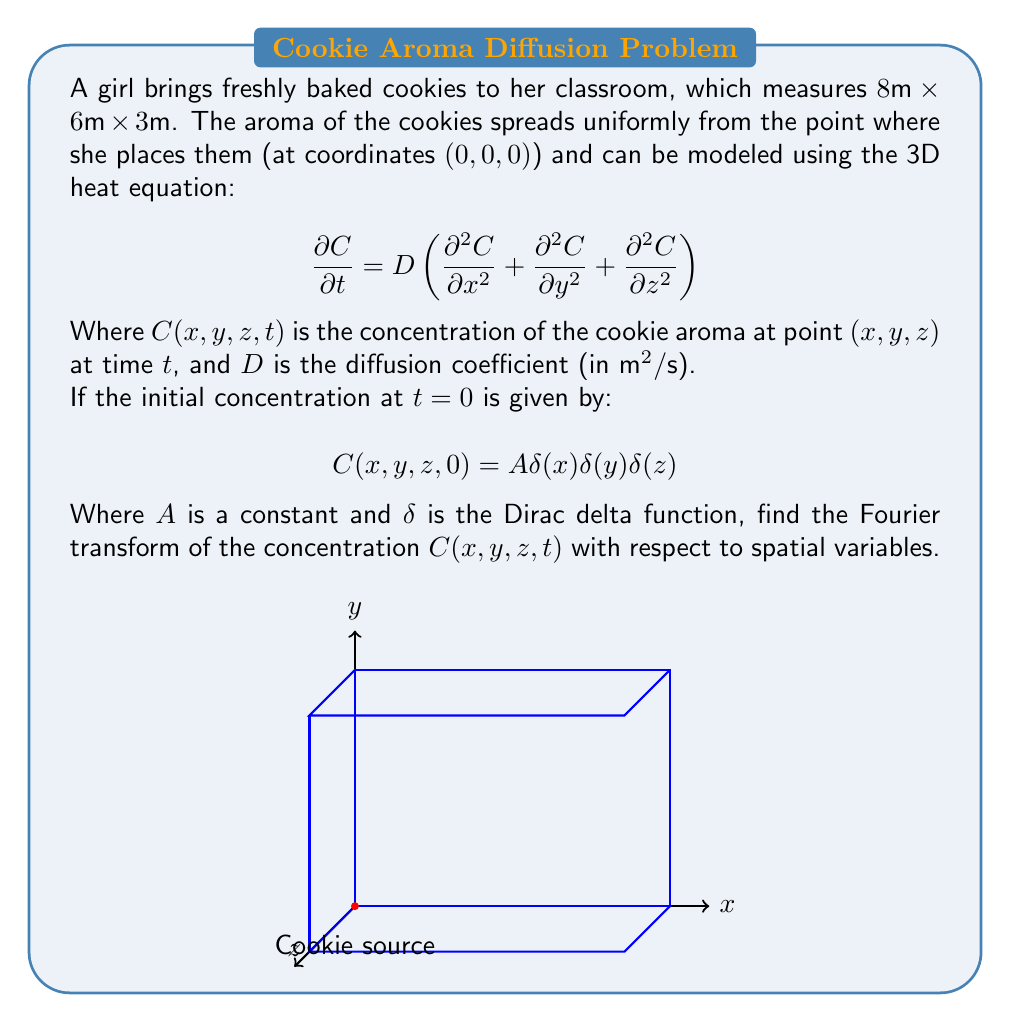What is the answer to this math problem? To solve this problem, we'll follow these steps:

1) First, we need to take the Fourier transform of the heat equation with respect to spatial variables. Let's denote the Fourier transform of $C(x,y,z,t)$ as $\hat{C}(k_x,k_y,k_z,t)$.

2) The Fourier transform of the left-hand side of the heat equation is:

   $$\mathcal{F}\left\{\frac{\partial C}{\partial t}\right\} = \frac{\partial \hat{C}}{\partial t}$$

3) For the right-hand side, we use the property that the Fourier transform of a second derivative is multiplication by $-k^2$:

   $$\mathcal{F}\left\{D\left(\frac{\partial^2 C}{\partial x^2} + \frac{\partial^2 C}{\partial y^2} + \frac{\partial^2 C}{\partial z^2}\right)\right\} = D(-k_x^2-k_y^2-k_z^2)\hat{C}$$

4) Therefore, the Fourier transformed heat equation is:

   $$\frac{\partial \hat{C}}{\partial t} = -D(k_x^2+k_y^2+k_z^2)\hat{C}$$

5) This is a first-order ordinary differential equation in $t$, with solution:

   $$\hat{C}(k_x,k_y,k_z,t) = \hat{C}(k_x,k_y,k_z,0)e^{-D(k_x^2+k_y^2+k_z^2)t}$$

6) Now, we need to find $\hat{C}(k_x,k_y,k_z,0)$, which is the Fourier transform of the initial condition:

   $$\hat{C}(k_x,k_y,k_z,0) = \mathcal{F}\{A\delta(x)\delta(y)\delta(z)\} = A$$

   This is because the Fourier transform of a delta function is a constant.

7) Therefore, the final solution for the Fourier transform of the concentration is:

   $$\hat{C}(k_x,k_y,k_z,t) = Ae^{-D(k_x^2+k_y^2+k_z^2)t}$$
Answer: $\hat{C}(k_x,k_y,k_z,t) = Ae^{-D(k_x^2+k_y^2+k_z^2)t}$ 